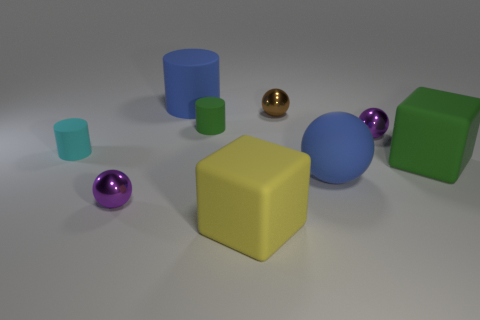What is the shape of the tiny object that is in front of the green matte cylinder and right of the yellow thing? sphere 